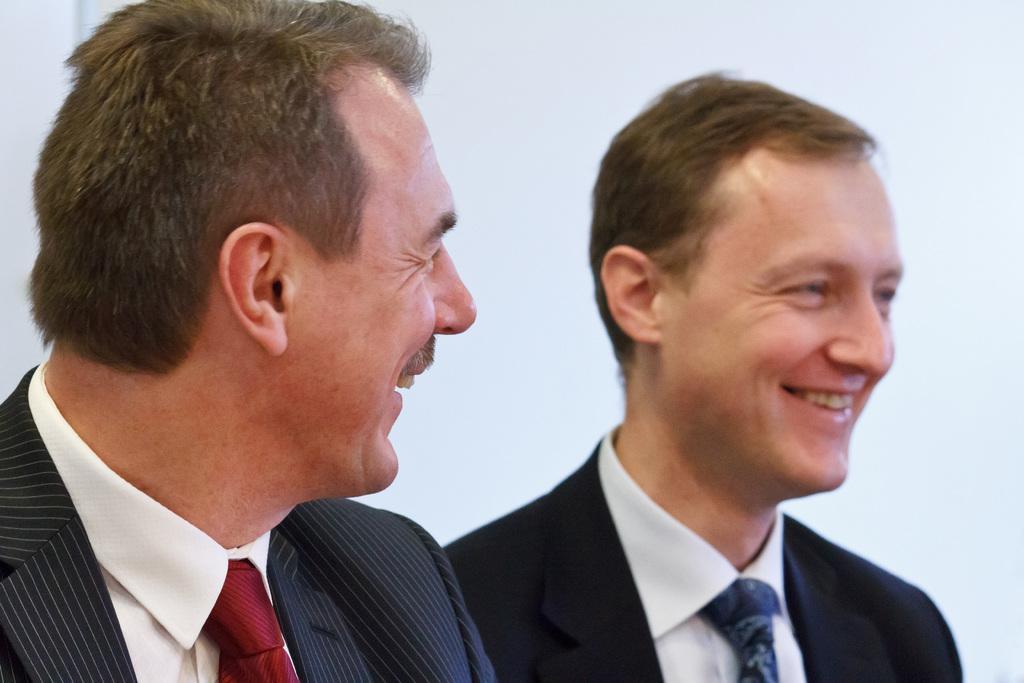Can you describe this image briefly? In this image we can see two persons with a smiling face and we can also see the white background. 